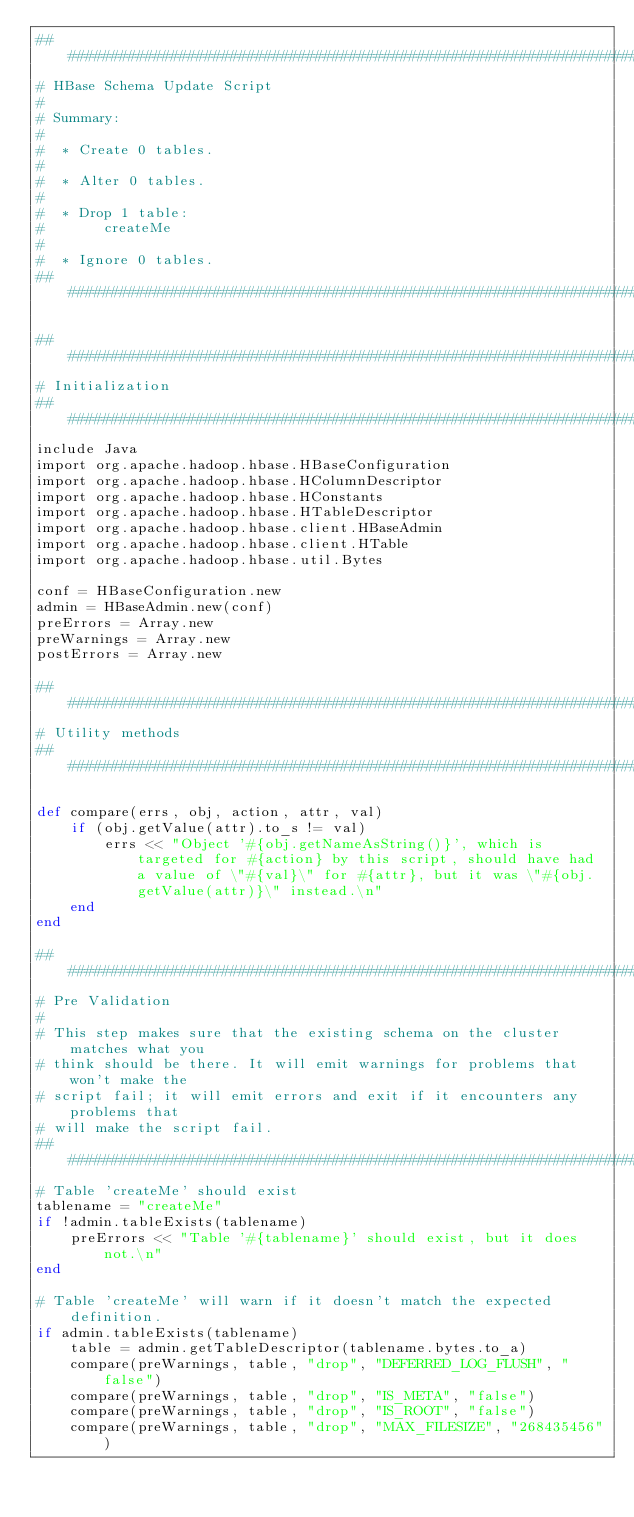Convert code to text. <code><loc_0><loc_0><loc_500><loc_500><_Ruby_>###############################################################################
# HBase Schema Update Script
#
# Summary:
#
#  * Create 0 tables.
#
#  * Alter 0 tables.
#
#  * Drop 1 table:
#       createMe
#
#  * Ignore 0 tables.
###############################################################################

###############################################################################
# Initialization
###############################################################################
include Java
import org.apache.hadoop.hbase.HBaseConfiguration
import org.apache.hadoop.hbase.HColumnDescriptor
import org.apache.hadoop.hbase.HConstants
import org.apache.hadoop.hbase.HTableDescriptor
import org.apache.hadoop.hbase.client.HBaseAdmin
import org.apache.hadoop.hbase.client.HTable
import org.apache.hadoop.hbase.util.Bytes

conf = HBaseConfiguration.new
admin = HBaseAdmin.new(conf)
preErrors = Array.new
preWarnings = Array.new
postErrors = Array.new

###############################################################################
# Utility methods
###############################################################################

def compare(errs, obj, action, attr, val)
    if (obj.getValue(attr).to_s != val)
        errs << "Object '#{obj.getNameAsString()}', which is targeted for #{action} by this script, should have had a value of \"#{val}\" for #{attr}, but it was \"#{obj.getValue(attr)}\" instead.\n"
    end
end

###############################################################################
# Pre Validation
#
# This step makes sure that the existing schema on the cluster matches what you
# think should be there. It will emit warnings for problems that won't make the
# script fail; it will emit errors and exit if it encounters any problems that
# will make the script fail.
###############################################################################
# Table 'createMe' should exist
tablename = "createMe"
if !admin.tableExists(tablename)
    preErrors << "Table '#{tablename}' should exist, but it does not.\n"
end

# Table 'createMe' will warn if it doesn't match the expected definition.
if admin.tableExists(tablename)
    table = admin.getTableDescriptor(tablename.bytes.to_a)
    compare(preWarnings, table, "drop", "DEFERRED_LOG_FLUSH", "false")
    compare(preWarnings, table, "drop", "IS_META", "false")
    compare(preWarnings, table, "drop", "IS_ROOT", "false")
    compare(preWarnings, table, "drop", "MAX_FILESIZE", "268435456")</code> 